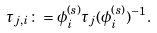Convert formula to latex. <formula><loc_0><loc_0><loc_500><loc_500>\tau _ { j , i } \colon = \phi _ { i } ^ { ( s ) } \tau _ { j } ( \phi _ { i } ^ { ( s ) } ) ^ { - 1 } .</formula> 